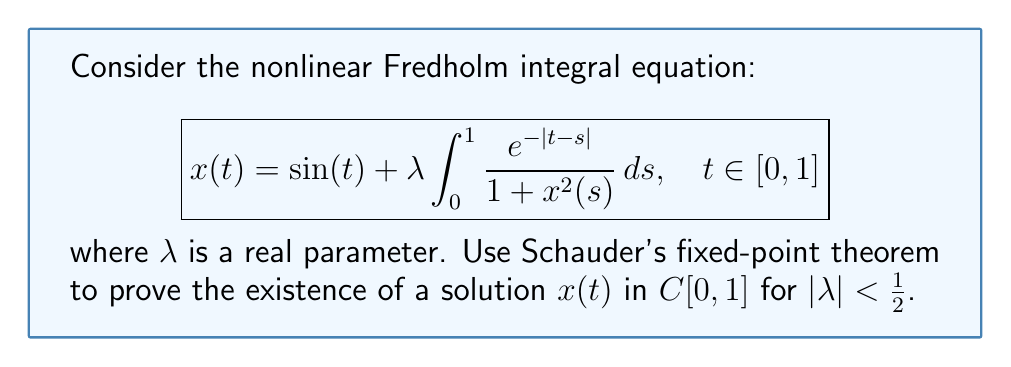Could you help me with this problem? To apply Schauder's fixed-point theorem, we need to define an operator $T$ and show that it satisfies the conditions of the theorem:

1. Define the operator $T: C[0,1] \to C[0,1]$ as:
   $$(Tx)(t) = \sin(t) + \lambda \int_0^1 \frac{e^{-|t-s|}}{1 + x^2(s)} ds$$

2. Show that $T$ maps a closed, bounded, and convex set into itself:
   Let $M = \max_{t\in[0,1]} |\sin(t)| + \frac{|\lambda|}{2} = 1 + \frac{|\lambda|}{2}$
   Define $B_M = \{x \in C[0,1] : \|x\|_{\infty} \leq M\}$

   For $x \in B_M$:
   $$\begin{align*}
   |(Tx)(t)| &\leq |\sin(t)| + |\lambda| \int_0^1 \frac{e^{-|t-s|}}{1 + x^2(s)} ds \\
   &\leq 1 + |\lambda| \int_0^1 e^{-|t-s|} ds \\
   &\leq 1 + |\lambda| \cdot \frac{1}{2} = M
   \end{align*}$$

   Thus, $T(B_M) \subseteq B_M$

3. Show that $T$ is continuous:
   Let $x_n \to x$ in $C[0,1]$. Then:
   $$\begin{align*}
   |(Tx_n)(t) - (Tx)(t)| &\leq |\lambda| \int_0^1 e^{-|t-s|} \left|\frac{1}{1 + x_n^2(s)} - \frac{1}{1 + x^2(s)}\right| ds \\
   &\leq |\lambda| \int_0^1 e^{-|t-s|} \frac{|x_n^2(s) - x^2(s)|}{(1 + x_n^2(s))(1 + x^2(s))} ds \\
   &\leq |\lambda| \|x_n - x\|_{\infty} \cdot \|x_n + x\|_{\infty} \int_0^1 e^{-|t-s|} ds \\
   &\leq \frac{|\lambda|}{2} \|x_n - x\|_{\infty} \cdot \|x_n + x\|_{\infty}
   \end{align*}$$

   As $x_n \to x$, $\|Tx_n - Tx\|_{\infty} \to 0$, proving continuity.

4. Show that $T(B_M)$ is relatively compact:
   Use Arzelà-Ascoli theorem:
   - $T(B_M)$ is uniformly bounded (shown in step 2)
   - $T(B_M)$ is equicontinuous:
     For $t_1, t_2 \in [0,1]$ and $x \in B_M$:
     $$\begin{align*}
     |(Tx)(t_1) - (Tx)(t_2)| &\leq |\sin(t_1) - \sin(t_2)| + \\
     &\quad |\lambda| \int_0^1 |e^{-|t_1-s|} - e^{-|t_2-s|}| \frac{ds}{1 + x^2(s)} \\
     &\leq |t_1 - t_2| + |\lambda| \int_0^1 |e^{-|t_1-s|} - e^{-|t_2-s|}| ds \\
     &\leq |t_1 - t_2| + |\lambda| \cdot 2|t_1 - t_2|
     \end{align*}$$

     This proves equicontinuity.

By Schauder's fixed-point theorem, $T$ has a fixed point in $B_M$, which is a solution to the integral equation.
Answer: Existence of a solution in $C[0,1]$ for $|\lambda| < \frac{1}{2}$. 